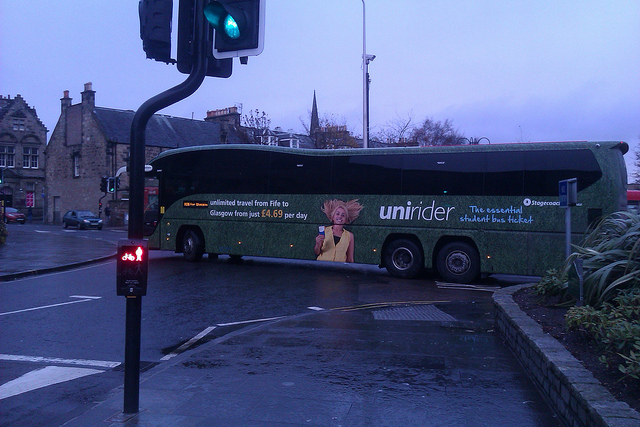Describe how the weather in the image might affect the daily routine of people visible in the image. The weather, appearing damp and overcast, suggests it either recently rained or drizzled. This could affect people's routines by prompting them to carry umbrellas, wear waterproof clothing, and perhaps hurry along the pavements to avoid prolonged exposure to the wet conditions. The wet roads might also lead drivers to be more cautious, adjusting their speed and braking distances to accommodate the slippery surfaces. Imagine a day in the life of a pedestrian walking along the street in the image. A pedestrian starts their day early, leaving their house just as the clouds part to reveal the sun peeking through. The damp air feels fresh. As they walk towards their destination, perhaps a nearby café, they navigate wet pavements, greeting familiar faces along the way. They appreciate the serenity after the rain, noticing reflections in puddles and the gentle sound of cars passing by, including the bus with its vibrant advertisement. They pick up a hot coffee, bask in a moment of warmth amidst the chill, and continue towards their day’s adventures — to work, study, or an intriguing new project around the corner. 